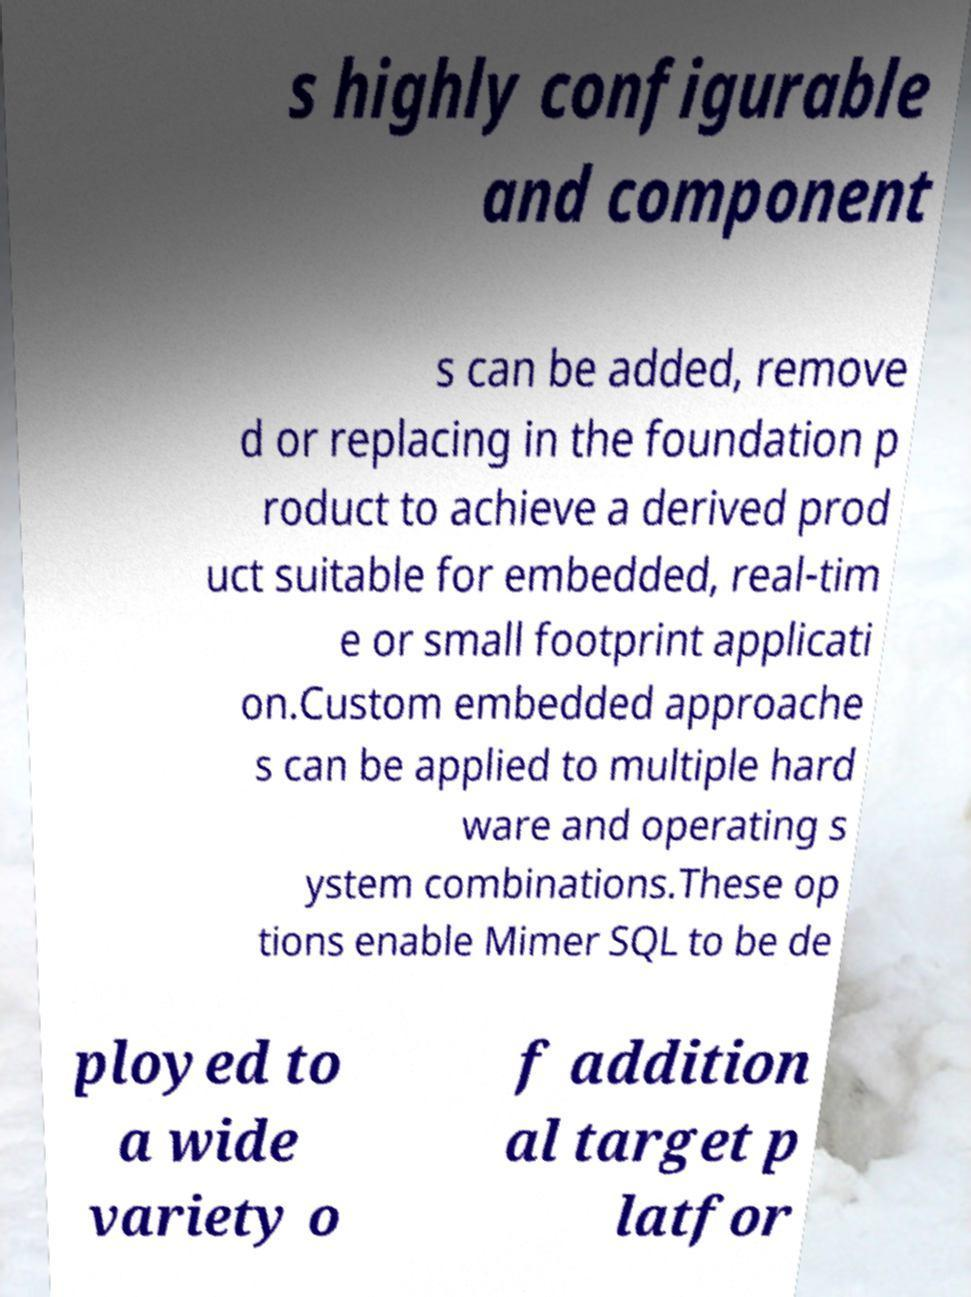I need the written content from this picture converted into text. Can you do that? s highly configurable and component s can be added, remove d or replacing in the foundation p roduct to achieve a derived prod uct suitable for embedded, real-tim e or small footprint applicati on.Custom embedded approache s can be applied to multiple hard ware and operating s ystem combinations.These op tions enable Mimer SQL to be de ployed to a wide variety o f addition al target p latfor 